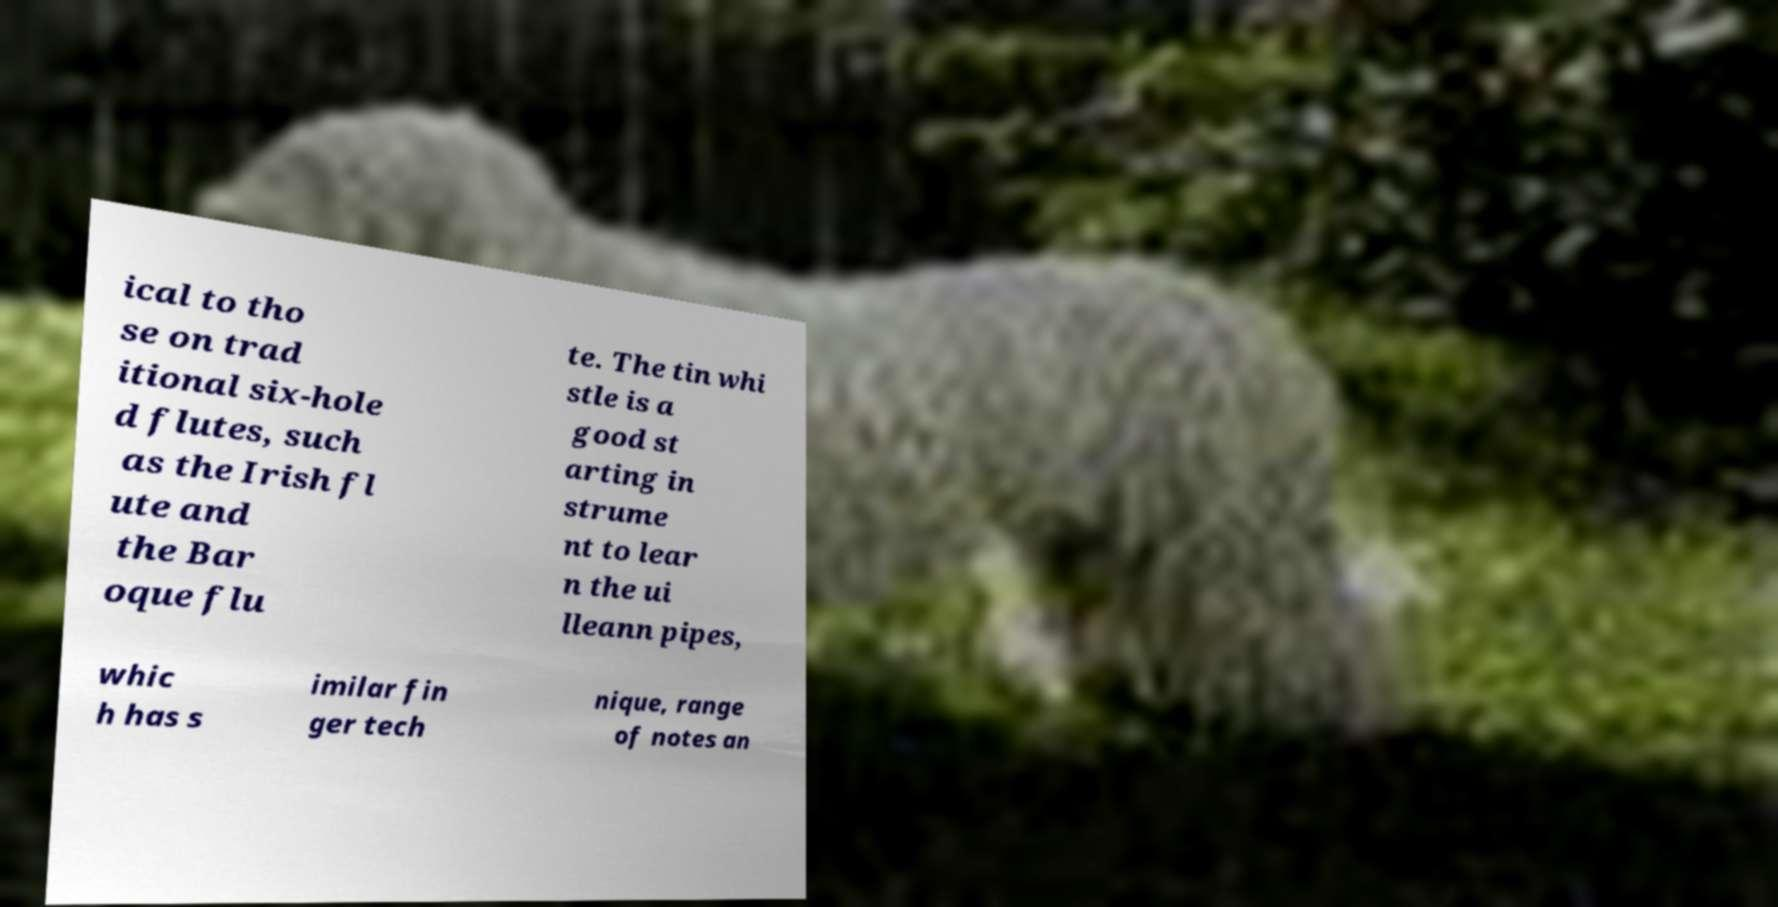Could you assist in decoding the text presented in this image and type it out clearly? ical to tho se on trad itional six-hole d flutes, such as the Irish fl ute and the Bar oque flu te. The tin whi stle is a good st arting in strume nt to lear n the ui lleann pipes, whic h has s imilar fin ger tech nique, range of notes an 